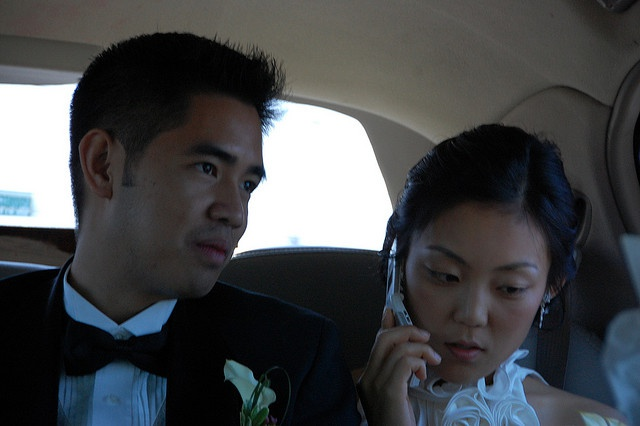Describe the objects in this image and their specific colors. I can see people in black, gray, darkblue, and blue tones, people in black and gray tones, tie in black, darkblue, and blue tones, and cell phone in black, blue, and gray tones in this image. 